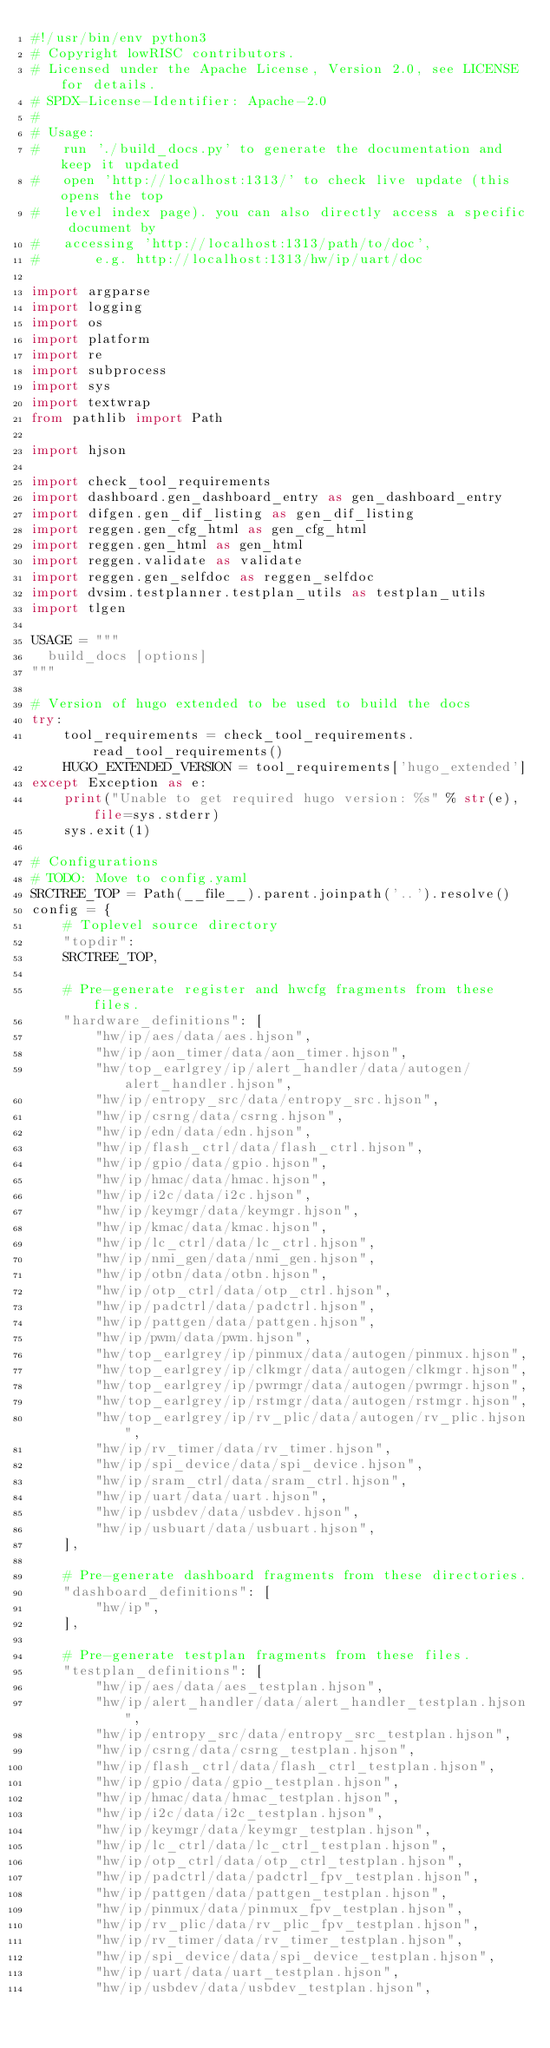<code> <loc_0><loc_0><loc_500><loc_500><_Python_>#!/usr/bin/env python3
# Copyright lowRISC contributors.
# Licensed under the Apache License, Version 2.0, see LICENSE for details.
# SPDX-License-Identifier: Apache-2.0
#
# Usage:
#   run './build_docs.py' to generate the documentation and keep it updated
#   open 'http://localhost:1313/' to check live update (this opens the top
#   level index page). you can also directly access a specific document by
#   accessing 'http://localhost:1313/path/to/doc',
#       e.g. http://localhost:1313/hw/ip/uart/doc

import argparse
import logging
import os
import platform
import re
import subprocess
import sys
import textwrap
from pathlib import Path

import hjson

import check_tool_requirements
import dashboard.gen_dashboard_entry as gen_dashboard_entry
import difgen.gen_dif_listing as gen_dif_listing
import reggen.gen_cfg_html as gen_cfg_html
import reggen.gen_html as gen_html
import reggen.validate as validate
import reggen.gen_selfdoc as reggen_selfdoc
import dvsim.testplanner.testplan_utils as testplan_utils
import tlgen

USAGE = """
  build_docs [options]
"""

# Version of hugo extended to be used to build the docs
try:
    tool_requirements = check_tool_requirements.read_tool_requirements()
    HUGO_EXTENDED_VERSION = tool_requirements['hugo_extended']
except Exception as e:
    print("Unable to get required hugo version: %s" % str(e), file=sys.stderr)
    sys.exit(1)

# Configurations
# TODO: Move to config.yaml
SRCTREE_TOP = Path(__file__).parent.joinpath('..').resolve()
config = {
    # Toplevel source directory
    "topdir":
    SRCTREE_TOP,

    # Pre-generate register and hwcfg fragments from these files.
    "hardware_definitions": [
        "hw/ip/aes/data/aes.hjson",
        "hw/ip/aon_timer/data/aon_timer.hjson",
        "hw/top_earlgrey/ip/alert_handler/data/autogen/alert_handler.hjson",
        "hw/ip/entropy_src/data/entropy_src.hjson",
        "hw/ip/csrng/data/csrng.hjson",
        "hw/ip/edn/data/edn.hjson",
        "hw/ip/flash_ctrl/data/flash_ctrl.hjson",
        "hw/ip/gpio/data/gpio.hjson",
        "hw/ip/hmac/data/hmac.hjson",
        "hw/ip/i2c/data/i2c.hjson",
        "hw/ip/keymgr/data/keymgr.hjson",
        "hw/ip/kmac/data/kmac.hjson",
        "hw/ip/lc_ctrl/data/lc_ctrl.hjson",
        "hw/ip/nmi_gen/data/nmi_gen.hjson",
        "hw/ip/otbn/data/otbn.hjson",
        "hw/ip/otp_ctrl/data/otp_ctrl.hjson",
        "hw/ip/padctrl/data/padctrl.hjson",
        "hw/ip/pattgen/data/pattgen.hjson",
        "hw/ip/pwm/data/pwm.hjson",
        "hw/top_earlgrey/ip/pinmux/data/autogen/pinmux.hjson",
        "hw/top_earlgrey/ip/clkmgr/data/autogen/clkmgr.hjson",
        "hw/top_earlgrey/ip/pwrmgr/data/autogen/pwrmgr.hjson",
        "hw/top_earlgrey/ip/rstmgr/data/autogen/rstmgr.hjson",
        "hw/top_earlgrey/ip/rv_plic/data/autogen/rv_plic.hjson",
        "hw/ip/rv_timer/data/rv_timer.hjson",
        "hw/ip/spi_device/data/spi_device.hjson",
        "hw/ip/sram_ctrl/data/sram_ctrl.hjson",
        "hw/ip/uart/data/uart.hjson",
        "hw/ip/usbdev/data/usbdev.hjson",
        "hw/ip/usbuart/data/usbuart.hjson",
    ],

    # Pre-generate dashboard fragments from these directories.
    "dashboard_definitions": [
        "hw/ip",
    ],

    # Pre-generate testplan fragments from these files.
    "testplan_definitions": [
        "hw/ip/aes/data/aes_testplan.hjson",
        "hw/ip/alert_handler/data/alert_handler_testplan.hjson",
        "hw/ip/entropy_src/data/entropy_src_testplan.hjson",
        "hw/ip/csrng/data/csrng_testplan.hjson",
        "hw/ip/flash_ctrl/data/flash_ctrl_testplan.hjson",
        "hw/ip/gpio/data/gpio_testplan.hjson",
        "hw/ip/hmac/data/hmac_testplan.hjson",
        "hw/ip/i2c/data/i2c_testplan.hjson",
        "hw/ip/keymgr/data/keymgr_testplan.hjson",
        "hw/ip/lc_ctrl/data/lc_ctrl_testplan.hjson",
        "hw/ip/otp_ctrl/data/otp_ctrl_testplan.hjson",
        "hw/ip/padctrl/data/padctrl_fpv_testplan.hjson",
        "hw/ip/pattgen/data/pattgen_testplan.hjson",
        "hw/ip/pinmux/data/pinmux_fpv_testplan.hjson",
        "hw/ip/rv_plic/data/rv_plic_fpv_testplan.hjson",
        "hw/ip/rv_timer/data/rv_timer_testplan.hjson",
        "hw/ip/spi_device/data/spi_device_testplan.hjson",
        "hw/ip/uart/data/uart_testplan.hjson",
        "hw/ip/usbdev/data/usbdev_testplan.hjson",</code> 